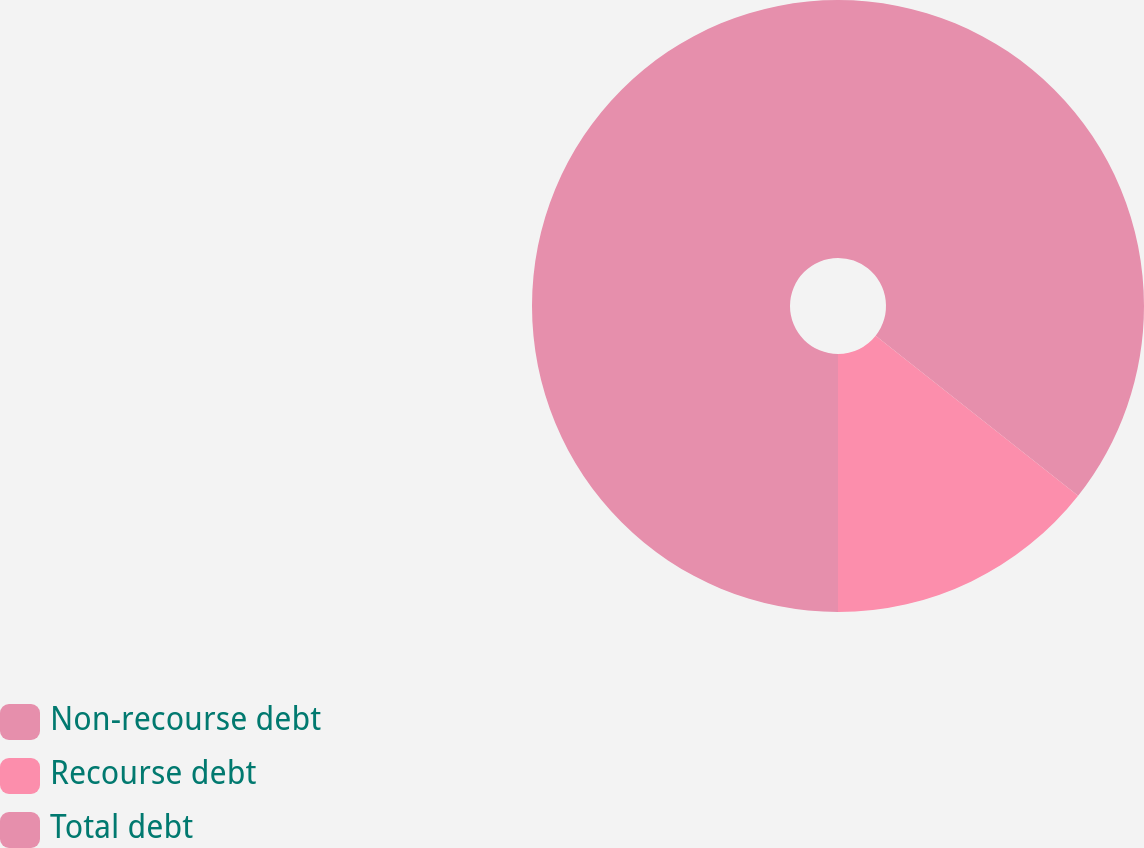Convert chart. <chart><loc_0><loc_0><loc_500><loc_500><pie_chart><fcel>Non-recourse debt<fcel>Recourse debt<fcel>Total debt<nl><fcel>35.64%<fcel>14.36%<fcel>50.0%<nl></chart> 